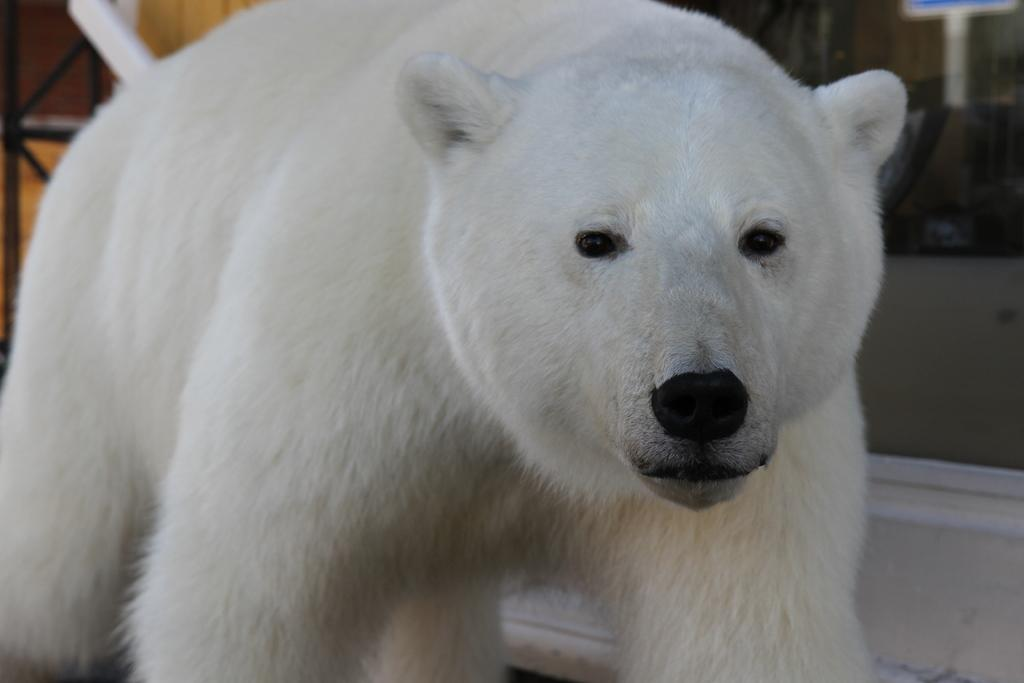What animal is present in the image? There is a polar bear in the image. What is the color of the polar bear? The polar bear is white in color. What grade does the polar bear receive for its performance in the image? There is no performance or grading system present in the image, as it features a polar bear. 